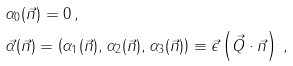Convert formula to latex. <formula><loc_0><loc_0><loc_500><loc_500>& \alpha _ { 0 } ( \vec { n } ) = 0 \, , \\ & { \vec { \alpha } } ( \vec { n } ) = \left ( \alpha _ { 1 } ( \vec { n } ) , \alpha _ { 2 } ( \vec { n } ) , \alpha _ { 3 } ( \vec { n } ) \right ) \equiv \vec { \epsilon } \left ( { \vec { Q } } \cdot { \vec { n } } \right ) \, ,</formula> 